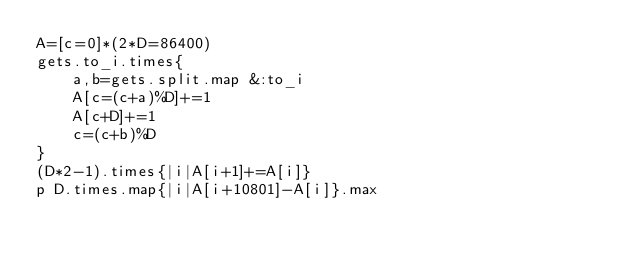Convert code to text. <code><loc_0><loc_0><loc_500><loc_500><_Ruby_>A=[c=0]*(2*D=86400)
gets.to_i.times{
	a,b=gets.split.map &:to_i
	A[c=(c+a)%D]+=1
	A[c+D]+=1
	c=(c+b)%D
}
(D*2-1).times{|i|A[i+1]+=A[i]}
p D.times.map{|i|A[i+10801]-A[i]}.max</code> 